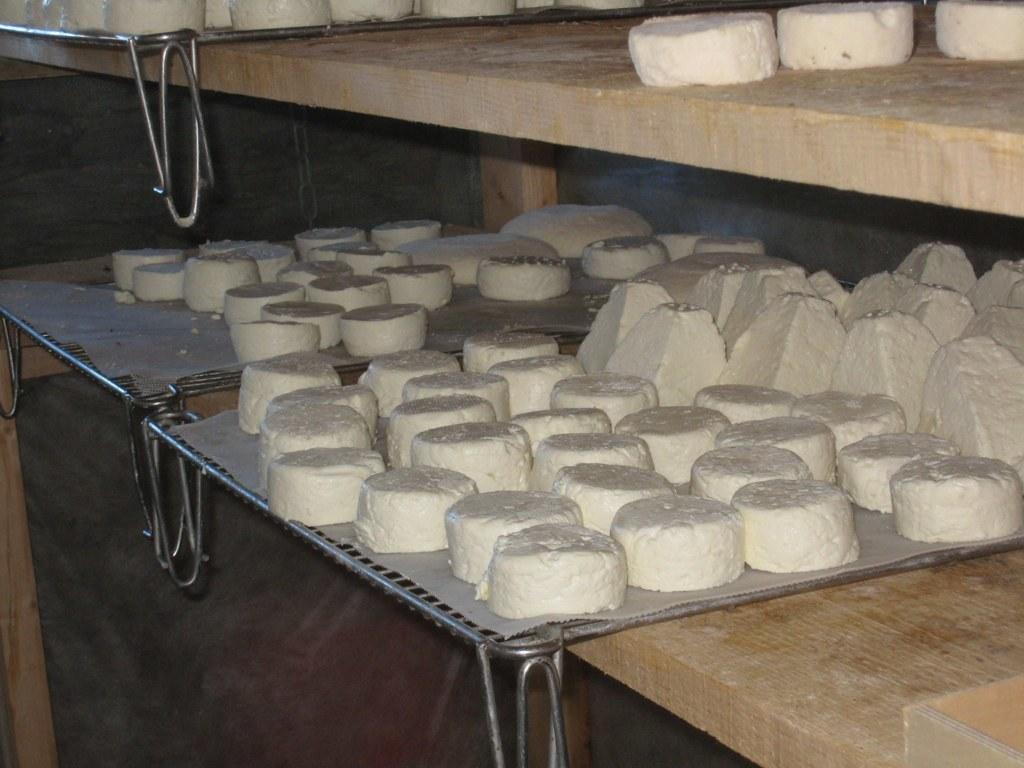What type of objects are present in the image? There are food items in the image. How are the food items arranged or presented? The food items are on metal plates. What is supporting the metal plates in the image? The metal plates are on wooden platforms. What type of tax is being discussed in the image? There is no discussion of tax in the image; it features food items on metal plates on wooden platforms. 